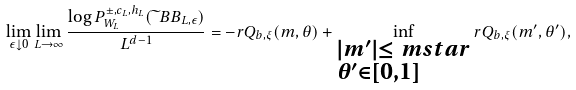<formula> <loc_0><loc_0><loc_500><loc_500>\lim _ { \epsilon \downarrow 0 } \lim _ { L \to \infty } \frac { \log P _ { W _ { L } } ^ { \pm , c _ { L } , h _ { L } } ( \widetilde { \ } B B _ { L , \epsilon } ) } { L ^ { d - 1 } } = - r Q _ { b , \xi } ( m , \theta ) + \inf _ { \begin{subarray} { c } | m ^ { \prime } | \leq \ m s t a r \\ \theta ^ { \prime } \in [ 0 , 1 ] \end{subarray} } r Q _ { b , \xi } ( m ^ { \prime } , \theta ^ { \prime } ) ,</formula> 